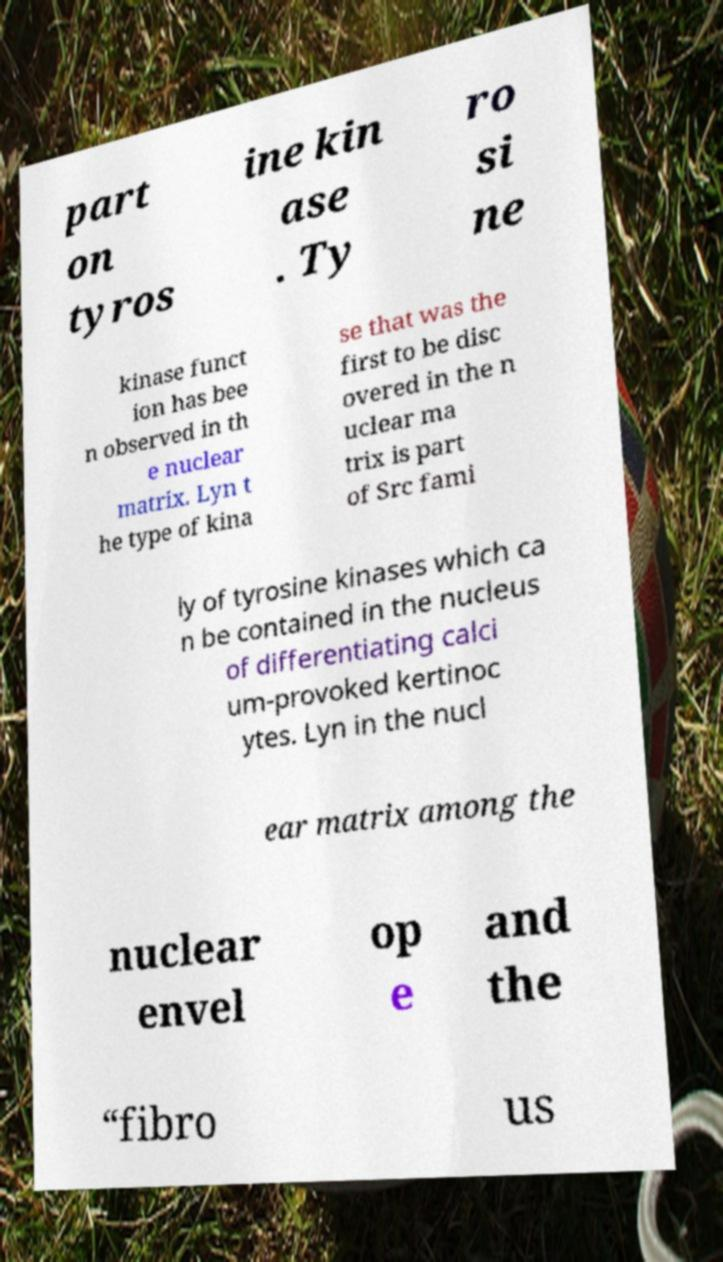What messages or text are displayed in this image? I need them in a readable, typed format. part on tyros ine kin ase . Ty ro si ne kinase funct ion has bee n observed in th e nuclear matrix. Lyn t he type of kina se that was the first to be disc overed in the n uclear ma trix is part of Src fami ly of tyrosine kinases which ca n be contained in the nucleus of differentiating calci um-provoked kertinoc ytes. Lyn in the nucl ear matrix among the nuclear envel op e and the “fibro us 